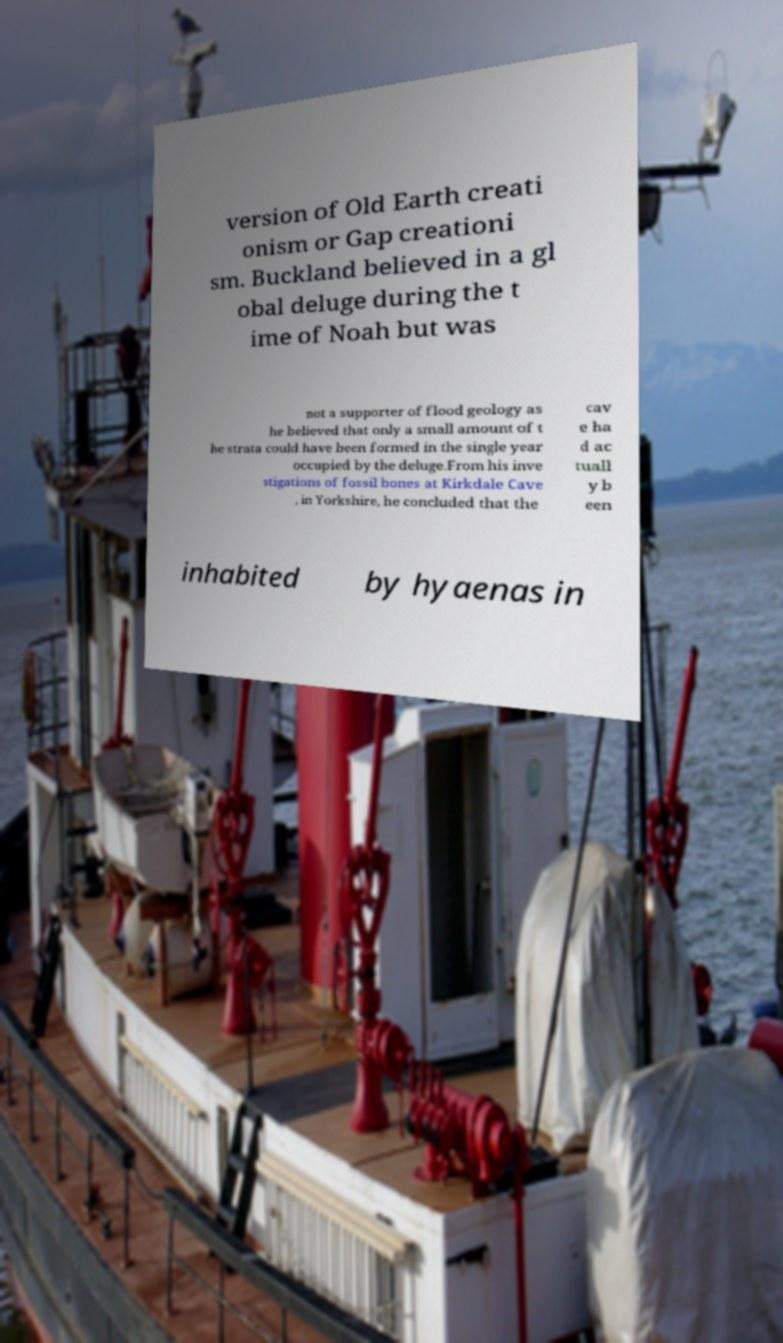Can you accurately transcribe the text from the provided image for me? version of Old Earth creati onism or Gap creationi sm. Buckland believed in a gl obal deluge during the t ime of Noah but was not a supporter of flood geology as he believed that only a small amount of t he strata could have been formed in the single year occupied by the deluge.From his inve stigations of fossil bones at Kirkdale Cave , in Yorkshire, he concluded that the cav e ha d ac tuall y b een inhabited by hyaenas in 